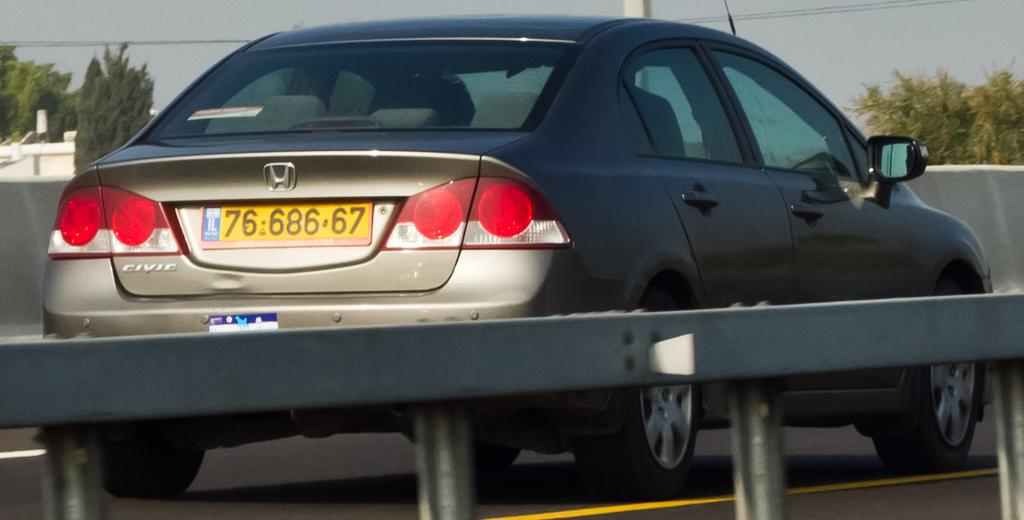<image>
Summarize the visual content of the image. the numbers 76 that are on the back of a car 